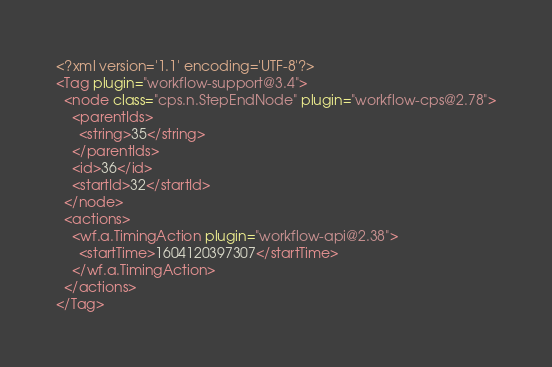<code> <loc_0><loc_0><loc_500><loc_500><_XML_><?xml version='1.1' encoding='UTF-8'?>
<Tag plugin="workflow-support@3.4">
  <node class="cps.n.StepEndNode" plugin="workflow-cps@2.78">
    <parentIds>
      <string>35</string>
    </parentIds>
    <id>36</id>
    <startId>32</startId>
  </node>
  <actions>
    <wf.a.TimingAction plugin="workflow-api@2.38">
      <startTime>1604120397307</startTime>
    </wf.a.TimingAction>
  </actions>
</Tag></code> 